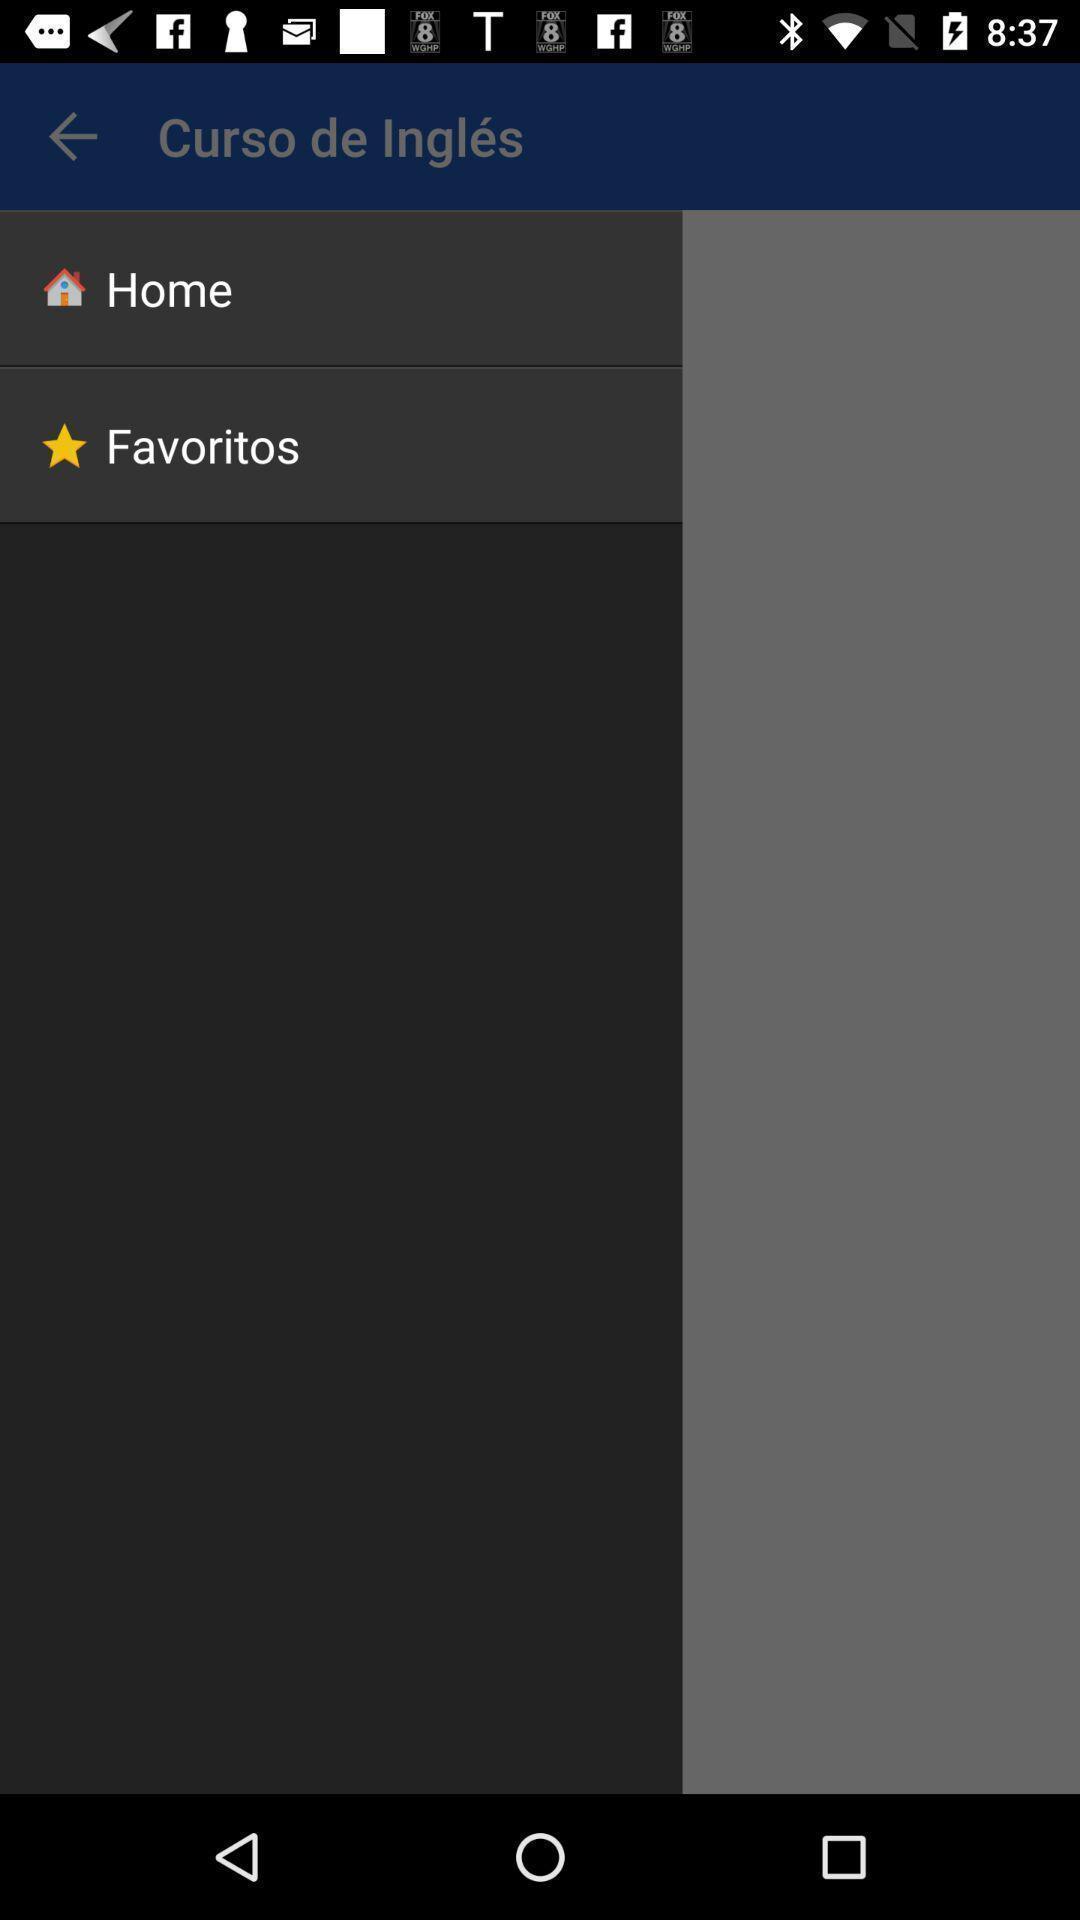Give me a summary of this screen capture. Screen showing home and favorites. 